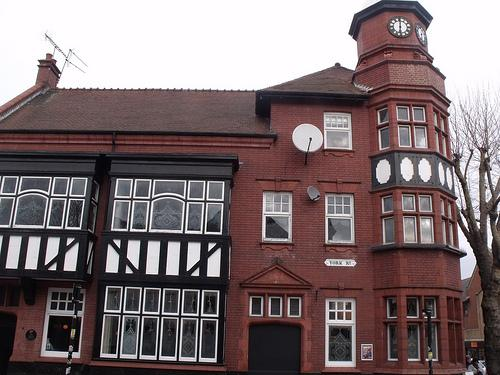If you were to promote this building as a real estate listing, give a brief description of the property highlighting its selling points. This charming red brick building boasts a brown rooftop, beautiful rows of windows adorned with white stained decor, a secure black door, numerous satellite dishes and antennas, and a unique clock feature to let you keep track of time. What type of building is depicted in the image and what are some of its key features? The image shows a red brick building with a brown rooftop, multiple rows of windows with white trims, a black door, antennas, satellite dishes, a clock displaying 600, and a sign on the facade. Describe the assortment and arrangement of windows on the building. The building has several rows of windows with white stained decor and black ledges, some arranged in groups of three, six, and two windows, and one with six windows in one frame. 